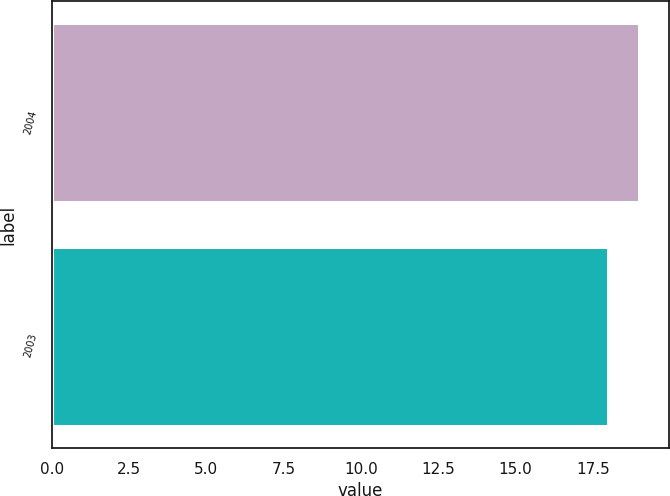<chart> <loc_0><loc_0><loc_500><loc_500><bar_chart><fcel>2004<fcel>2003<nl><fcel>19<fcel>18<nl></chart> 